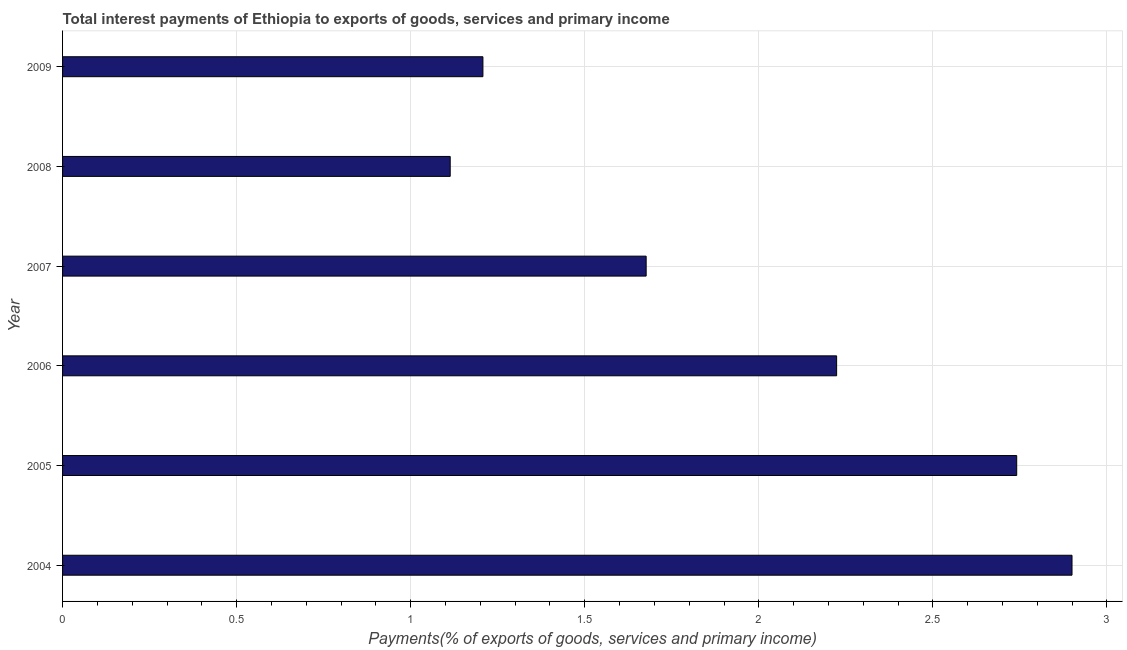Does the graph contain any zero values?
Offer a very short reply. No. What is the title of the graph?
Give a very brief answer. Total interest payments of Ethiopia to exports of goods, services and primary income. What is the label or title of the X-axis?
Make the answer very short. Payments(% of exports of goods, services and primary income). What is the total interest payments on external debt in 2005?
Make the answer very short. 2.74. Across all years, what is the maximum total interest payments on external debt?
Make the answer very short. 2.9. Across all years, what is the minimum total interest payments on external debt?
Your response must be concise. 1.11. In which year was the total interest payments on external debt maximum?
Give a very brief answer. 2004. What is the sum of the total interest payments on external debt?
Your answer should be very brief. 11.86. What is the difference between the total interest payments on external debt in 2005 and 2006?
Make the answer very short. 0.52. What is the average total interest payments on external debt per year?
Ensure brevity in your answer.  1.98. What is the median total interest payments on external debt?
Provide a succinct answer. 1.95. What is the ratio of the total interest payments on external debt in 2005 to that in 2008?
Make the answer very short. 2.46. What is the difference between the highest and the second highest total interest payments on external debt?
Provide a short and direct response. 0.16. What is the difference between the highest and the lowest total interest payments on external debt?
Your answer should be compact. 1.79. How many bars are there?
Offer a very short reply. 6. Are all the bars in the graph horizontal?
Offer a terse response. Yes. How many years are there in the graph?
Provide a succinct answer. 6. What is the Payments(% of exports of goods, services and primary income) of 2004?
Your answer should be very brief. 2.9. What is the Payments(% of exports of goods, services and primary income) of 2005?
Ensure brevity in your answer.  2.74. What is the Payments(% of exports of goods, services and primary income) of 2006?
Your answer should be very brief. 2.22. What is the Payments(% of exports of goods, services and primary income) in 2007?
Your answer should be very brief. 1.68. What is the Payments(% of exports of goods, services and primary income) in 2008?
Provide a short and direct response. 1.11. What is the Payments(% of exports of goods, services and primary income) of 2009?
Offer a very short reply. 1.21. What is the difference between the Payments(% of exports of goods, services and primary income) in 2004 and 2005?
Your answer should be very brief. 0.16. What is the difference between the Payments(% of exports of goods, services and primary income) in 2004 and 2006?
Your answer should be compact. 0.68. What is the difference between the Payments(% of exports of goods, services and primary income) in 2004 and 2007?
Ensure brevity in your answer.  1.22. What is the difference between the Payments(% of exports of goods, services and primary income) in 2004 and 2008?
Give a very brief answer. 1.79. What is the difference between the Payments(% of exports of goods, services and primary income) in 2004 and 2009?
Your response must be concise. 1.69. What is the difference between the Payments(% of exports of goods, services and primary income) in 2005 and 2006?
Provide a short and direct response. 0.52. What is the difference between the Payments(% of exports of goods, services and primary income) in 2005 and 2007?
Your answer should be very brief. 1.06. What is the difference between the Payments(% of exports of goods, services and primary income) in 2005 and 2008?
Make the answer very short. 1.63. What is the difference between the Payments(% of exports of goods, services and primary income) in 2005 and 2009?
Your response must be concise. 1.53. What is the difference between the Payments(% of exports of goods, services and primary income) in 2006 and 2007?
Ensure brevity in your answer.  0.55. What is the difference between the Payments(% of exports of goods, services and primary income) in 2006 and 2008?
Keep it short and to the point. 1.11. What is the difference between the Payments(% of exports of goods, services and primary income) in 2006 and 2009?
Your response must be concise. 1.02. What is the difference between the Payments(% of exports of goods, services and primary income) in 2007 and 2008?
Keep it short and to the point. 0.56. What is the difference between the Payments(% of exports of goods, services and primary income) in 2007 and 2009?
Your answer should be very brief. 0.47. What is the difference between the Payments(% of exports of goods, services and primary income) in 2008 and 2009?
Provide a succinct answer. -0.09. What is the ratio of the Payments(% of exports of goods, services and primary income) in 2004 to that in 2005?
Provide a short and direct response. 1.06. What is the ratio of the Payments(% of exports of goods, services and primary income) in 2004 to that in 2006?
Provide a short and direct response. 1.3. What is the ratio of the Payments(% of exports of goods, services and primary income) in 2004 to that in 2007?
Ensure brevity in your answer.  1.73. What is the ratio of the Payments(% of exports of goods, services and primary income) in 2004 to that in 2008?
Offer a terse response. 2.6. What is the ratio of the Payments(% of exports of goods, services and primary income) in 2004 to that in 2009?
Make the answer very short. 2.4. What is the ratio of the Payments(% of exports of goods, services and primary income) in 2005 to that in 2006?
Your response must be concise. 1.23. What is the ratio of the Payments(% of exports of goods, services and primary income) in 2005 to that in 2007?
Offer a terse response. 1.64. What is the ratio of the Payments(% of exports of goods, services and primary income) in 2005 to that in 2008?
Offer a terse response. 2.46. What is the ratio of the Payments(% of exports of goods, services and primary income) in 2005 to that in 2009?
Give a very brief answer. 2.27. What is the ratio of the Payments(% of exports of goods, services and primary income) in 2006 to that in 2007?
Offer a terse response. 1.33. What is the ratio of the Payments(% of exports of goods, services and primary income) in 2006 to that in 2008?
Your answer should be very brief. 2. What is the ratio of the Payments(% of exports of goods, services and primary income) in 2006 to that in 2009?
Give a very brief answer. 1.84. What is the ratio of the Payments(% of exports of goods, services and primary income) in 2007 to that in 2008?
Make the answer very short. 1.5. What is the ratio of the Payments(% of exports of goods, services and primary income) in 2007 to that in 2009?
Your response must be concise. 1.39. What is the ratio of the Payments(% of exports of goods, services and primary income) in 2008 to that in 2009?
Provide a short and direct response. 0.92. 